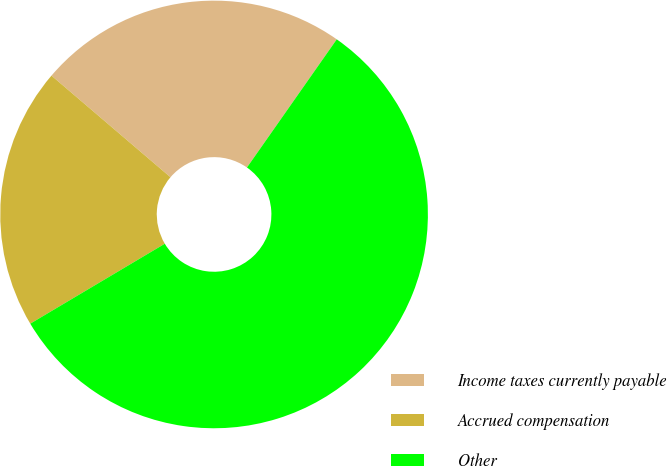<chart> <loc_0><loc_0><loc_500><loc_500><pie_chart><fcel>Income taxes currently payable<fcel>Accrued compensation<fcel>Other<nl><fcel>23.48%<fcel>19.78%<fcel>56.74%<nl></chart> 